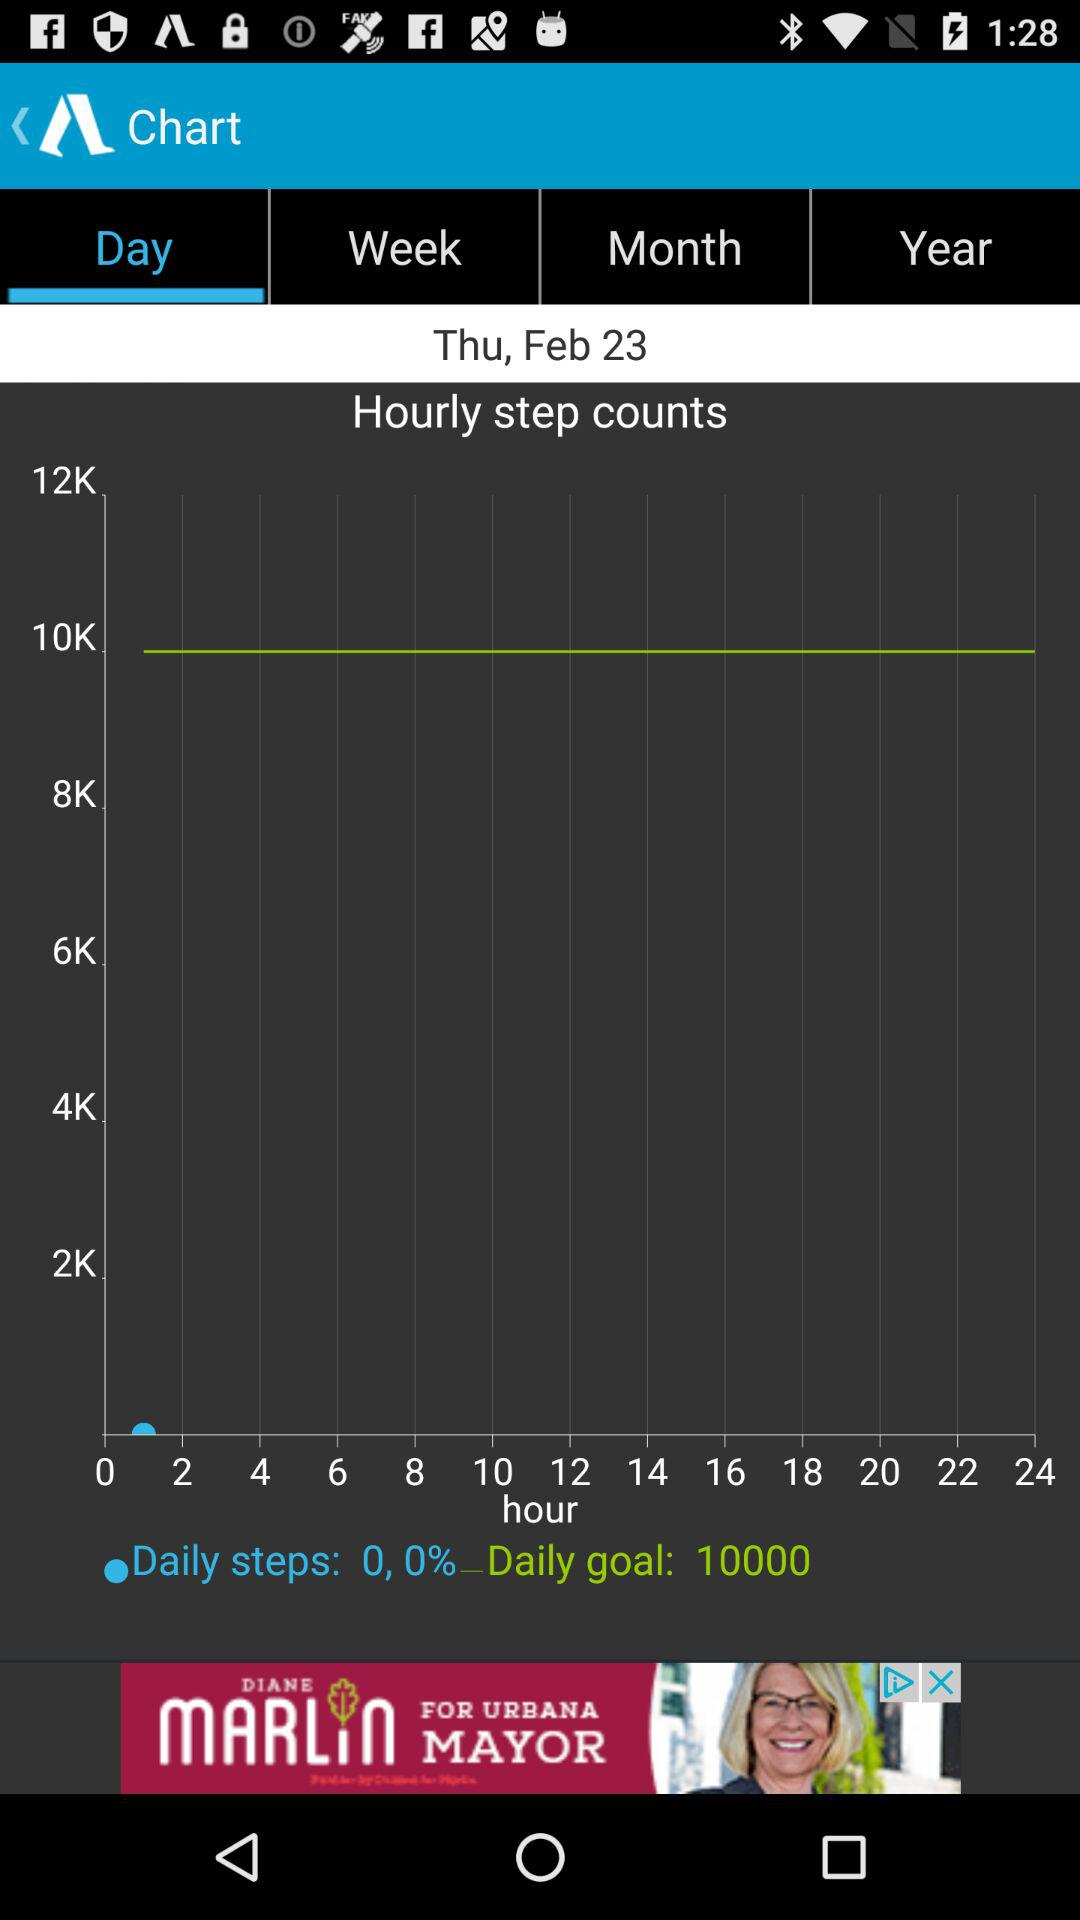What is the given count of daily steps? The given count of daily steps is 0. 